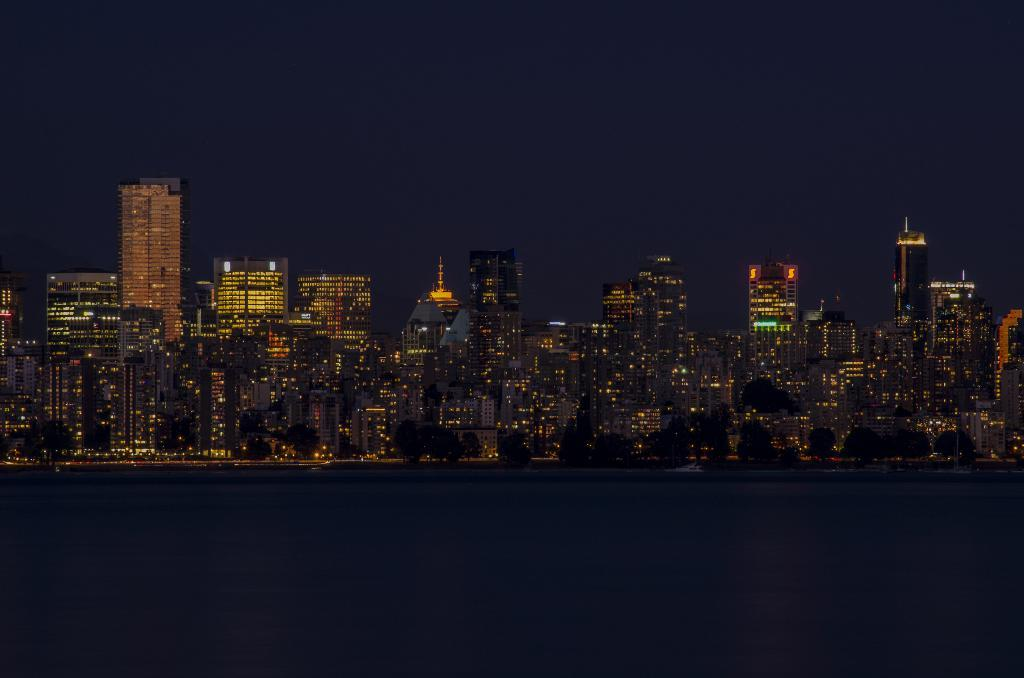What type of structures are illuminated in the image? There is a group of buildings with lights in the image. What natural elements can be seen in the image? There are trees in the image. What is the large body of water in the image? There is a large water body in the image. What can be seen above the buildings and trees in the image? The sky is visible in the image. What type of knee injury is visible in the image? There is no knee injury present in the image. What season is depicted in the image? The provided facts do not indicate a specific season, so it cannot be determined from the image. 